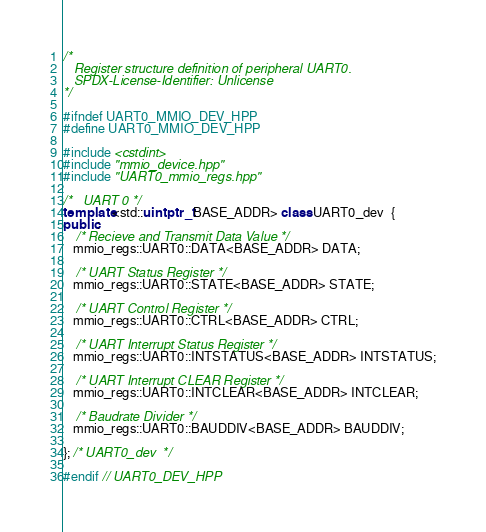Convert code to text. <code><loc_0><loc_0><loc_500><loc_500><_C++_>/*
   Register structure definition of peripheral UART0.
   SPDX-License-Identifier: Unlicense
*/

#ifndef UART0_MMIO_DEV_HPP
#define UART0_MMIO_DEV_HPP

#include <cstdint>
#include "mmio_device.hpp"
#include "UART0_mmio_regs.hpp"

/*   UART 0 */
template<std::uintptr_t BASE_ADDR> class UART0_dev  {
public:
    /* Recieve and Transmit Data Value */
   mmio_regs::UART0::DATA<BASE_ADDR> DATA;
   
    /* UART Status Register */
   mmio_regs::UART0::STATE<BASE_ADDR> STATE;
   
    /* UART Control Register */
   mmio_regs::UART0::CTRL<BASE_ADDR> CTRL;
   
    /* UART Interrupt Status Register */
   mmio_regs::UART0::INTSTATUS<BASE_ADDR> INTSTATUS;
   
    /* UART Interrupt CLEAR Register */
   mmio_regs::UART0::INTCLEAR<BASE_ADDR> INTCLEAR;
   
    /* Baudrate Divider */
   mmio_regs::UART0::BAUDDIV<BASE_ADDR> BAUDDIV;
   
}; /* UART0_dev  */

#endif // UART0_DEV_HPP</code> 